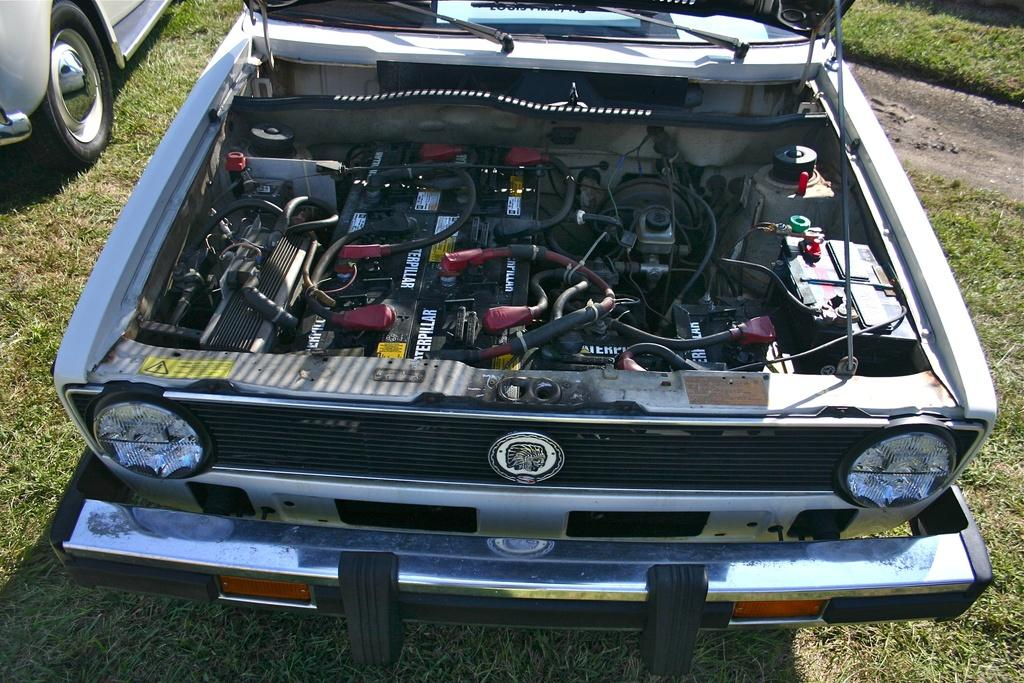What types of objects can be seen in the image? There are vehicles in the image. What is the terrain like in the image? There is a grassy land in the image. What type of destruction is the queen causing in the image? There is no queen or destruction present in the image; it features vehicles on a grassy land. 